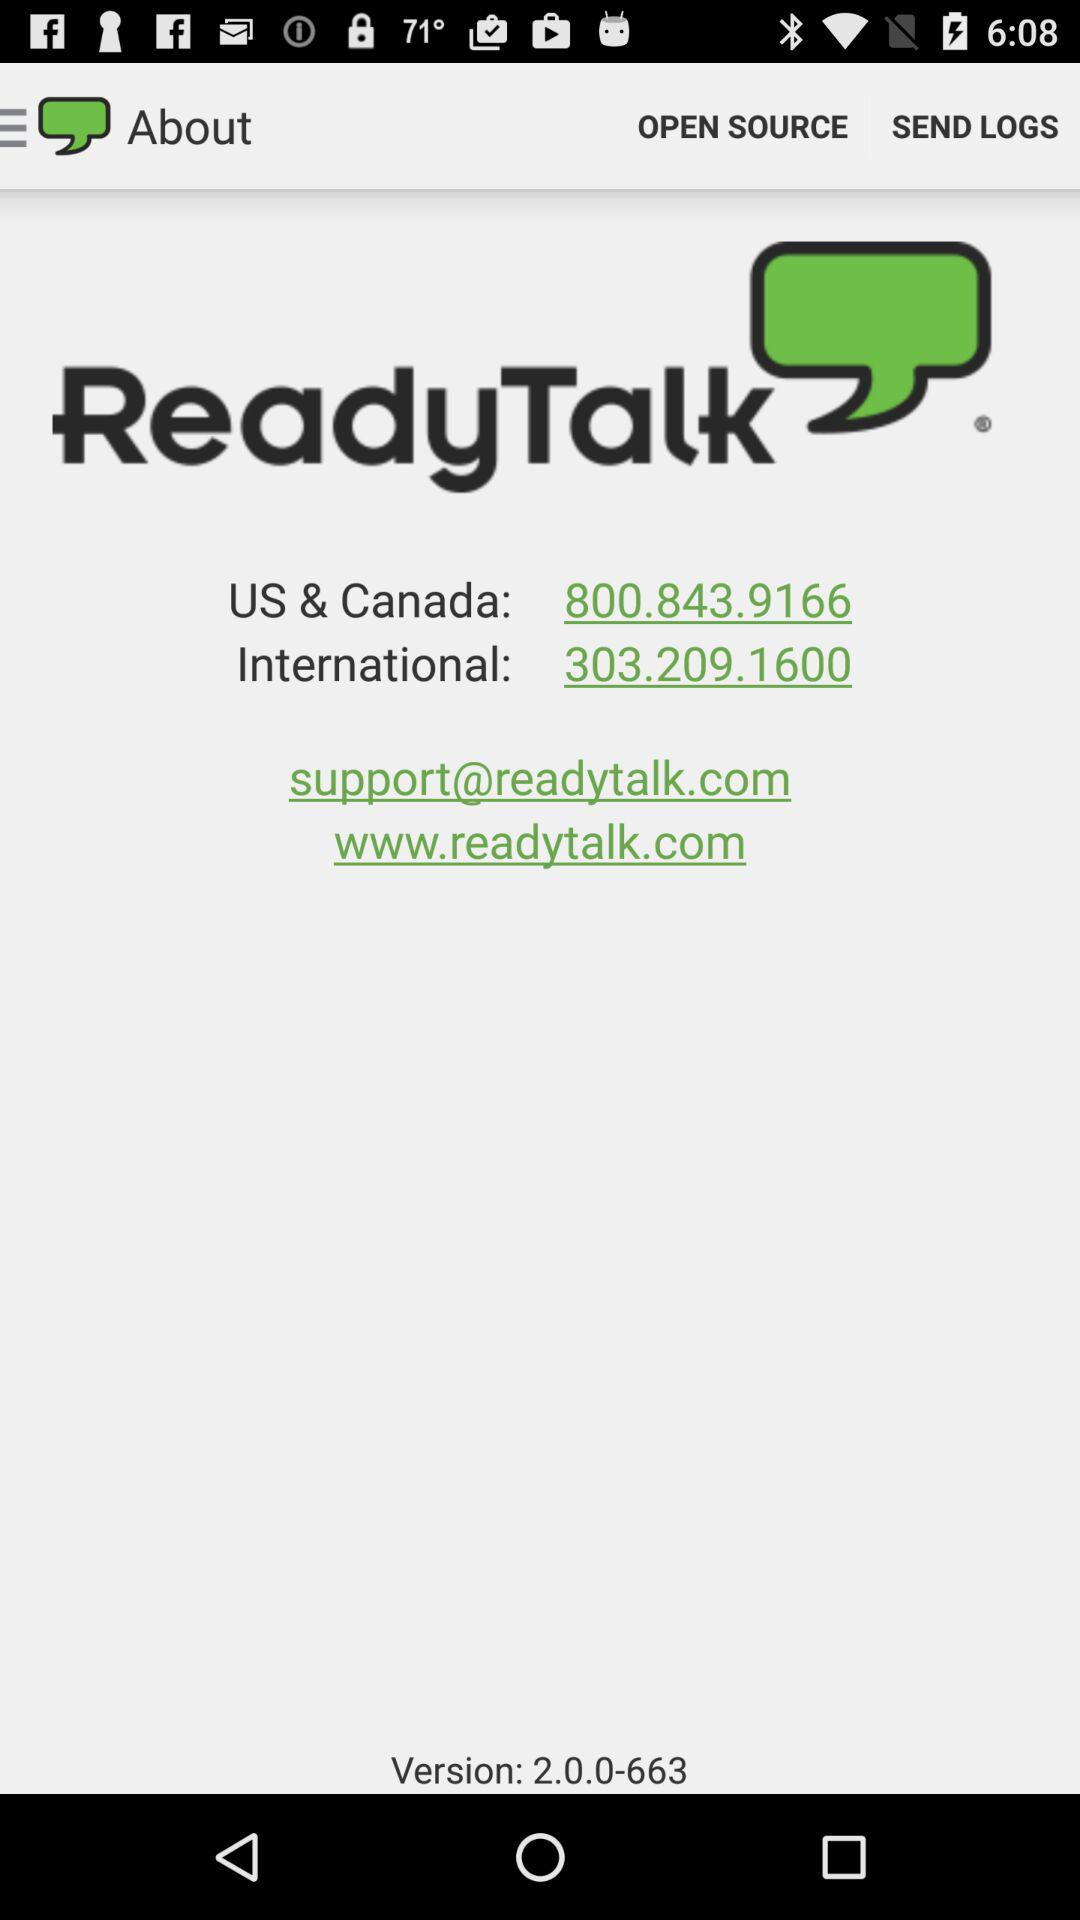What is the email address? The email address is support@readytalk.com. 